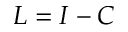<formula> <loc_0><loc_0><loc_500><loc_500>L = I - C</formula> 